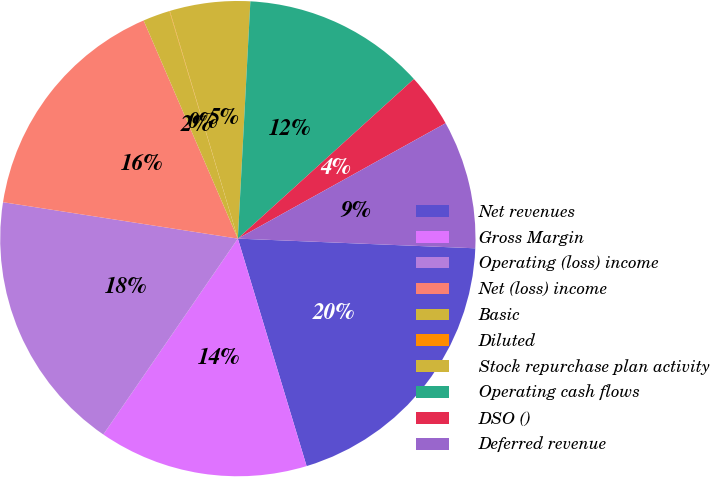<chart> <loc_0><loc_0><loc_500><loc_500><pie_chart><fcel>Net revenues<fcel>Gross Margin<fcel>Operating (loss) income<fcel>Net (loss) income<fcel>Basic<fcel>Diluted<fcel>Stock repurchase plan activity<fcel>Operating cash flows<fcel>DSO ()<fcel>Deferred revenue<nl><fcel>19.68%<fcel>14.25%<fcel>17.87%<fcel>16.06%<fcel>1.84%<fcel>0.03%<fcel>5.46%<fcel>12.44%<fcel>3.65%<fcel>8.72%<nl></chart> 